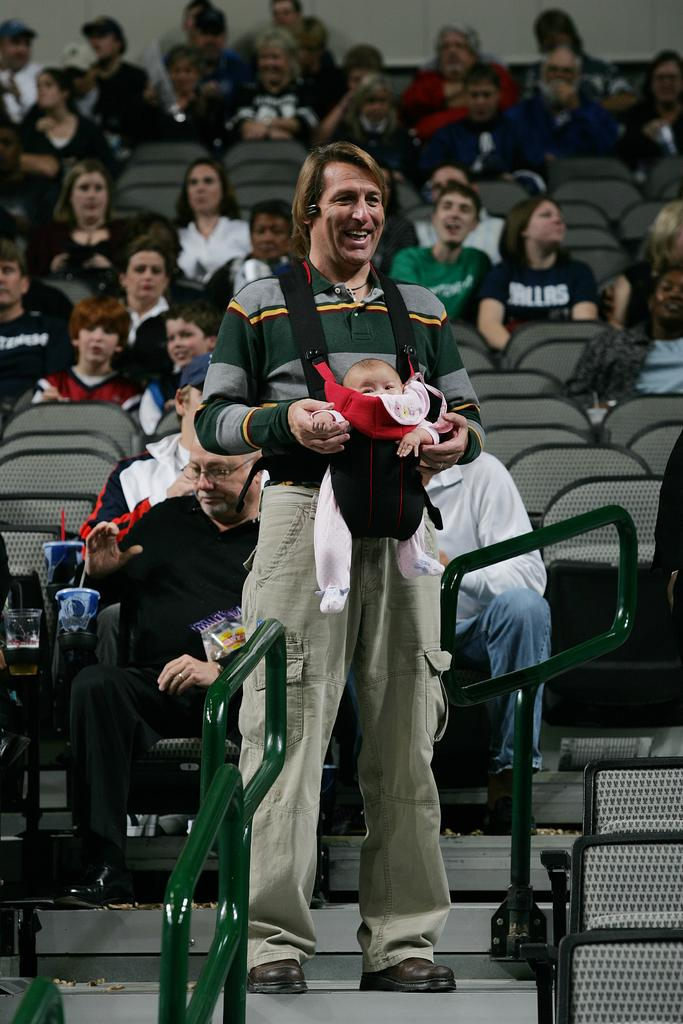What are the people in the image doing? There are people sitting on chairs in the image. What is the man in the image doing? The man is standing and holding a baby in the image. What can be seen near the people in the image? Railings are visible in the image. What else is present in the image besides the people and railings? There are objects present in the image. What architectural feature is visible in the image? There are stairs in the image. What type of butter is being used to grease the star in the image? There is no butter or star present in the image. What role does the father play in the image? The provided facts do not mention a father, so we cannot determine his role in the image. 